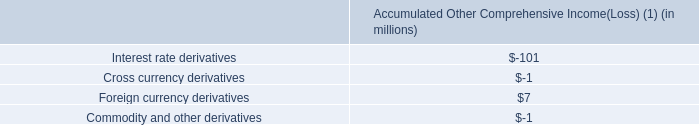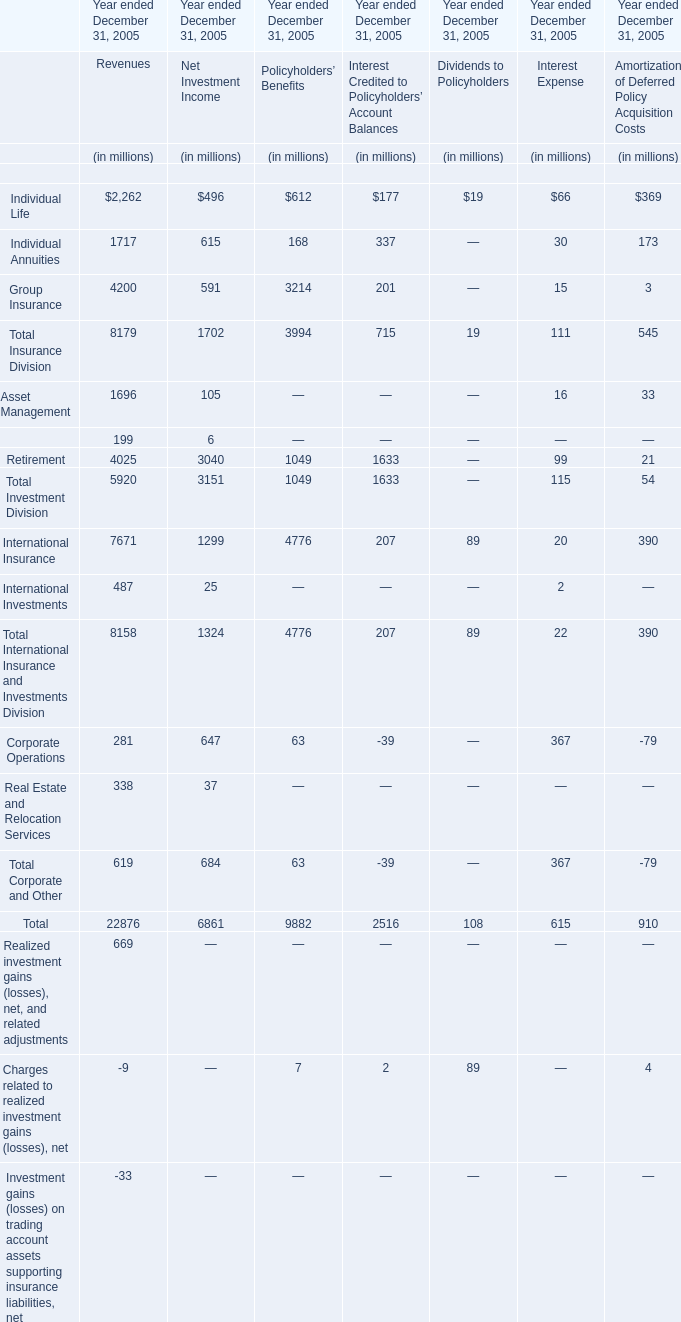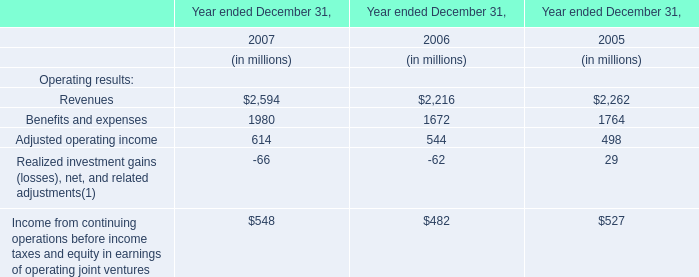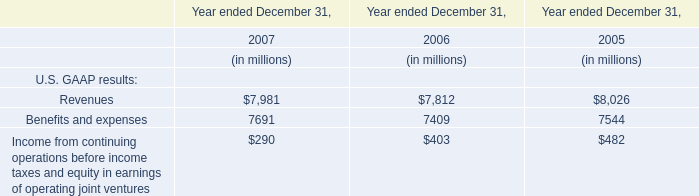What is the sum of Total Insurance Division for Financial Services Businesses for Net Investment Income in 2005 and Revenues for U.S. GAAP results in 2006? (in million) 
Computations: (1702 + 7812)
Answer: 9514.0. 